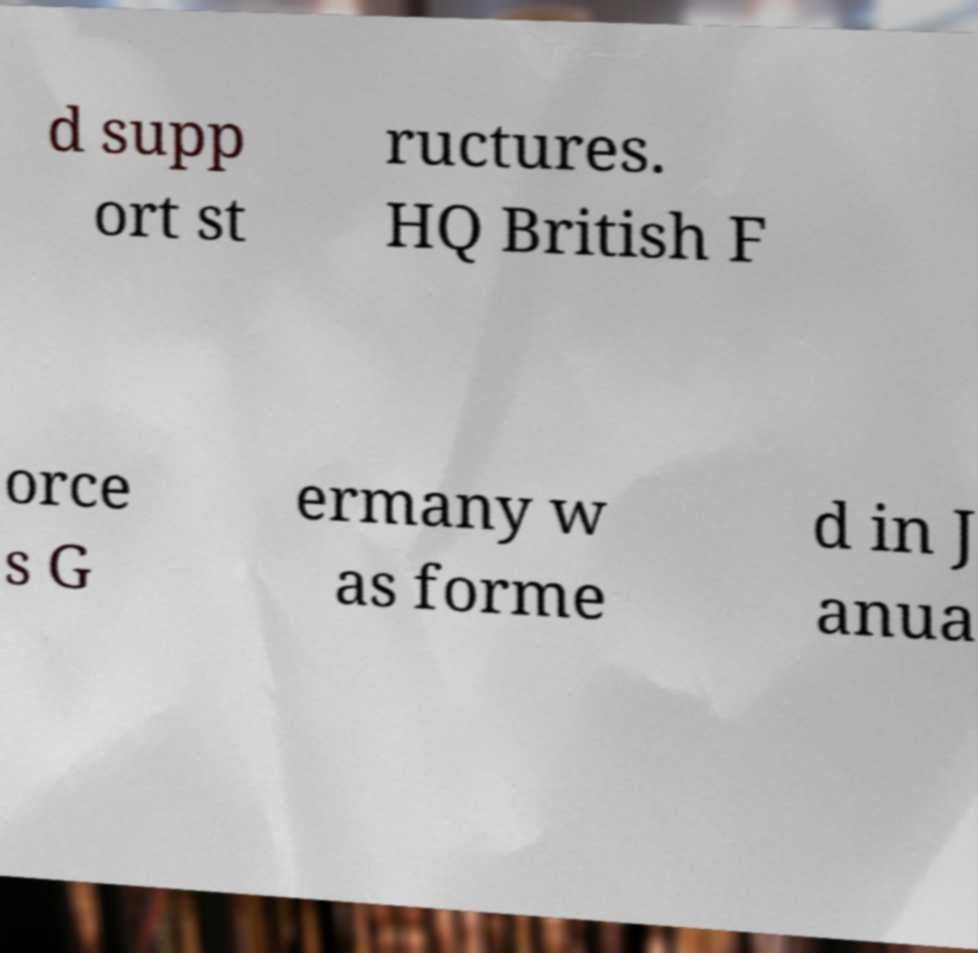Could you extract and type out the text from this image? d supp ort st ructures. HQ British F orce s G ermany w as forme d in J anua 